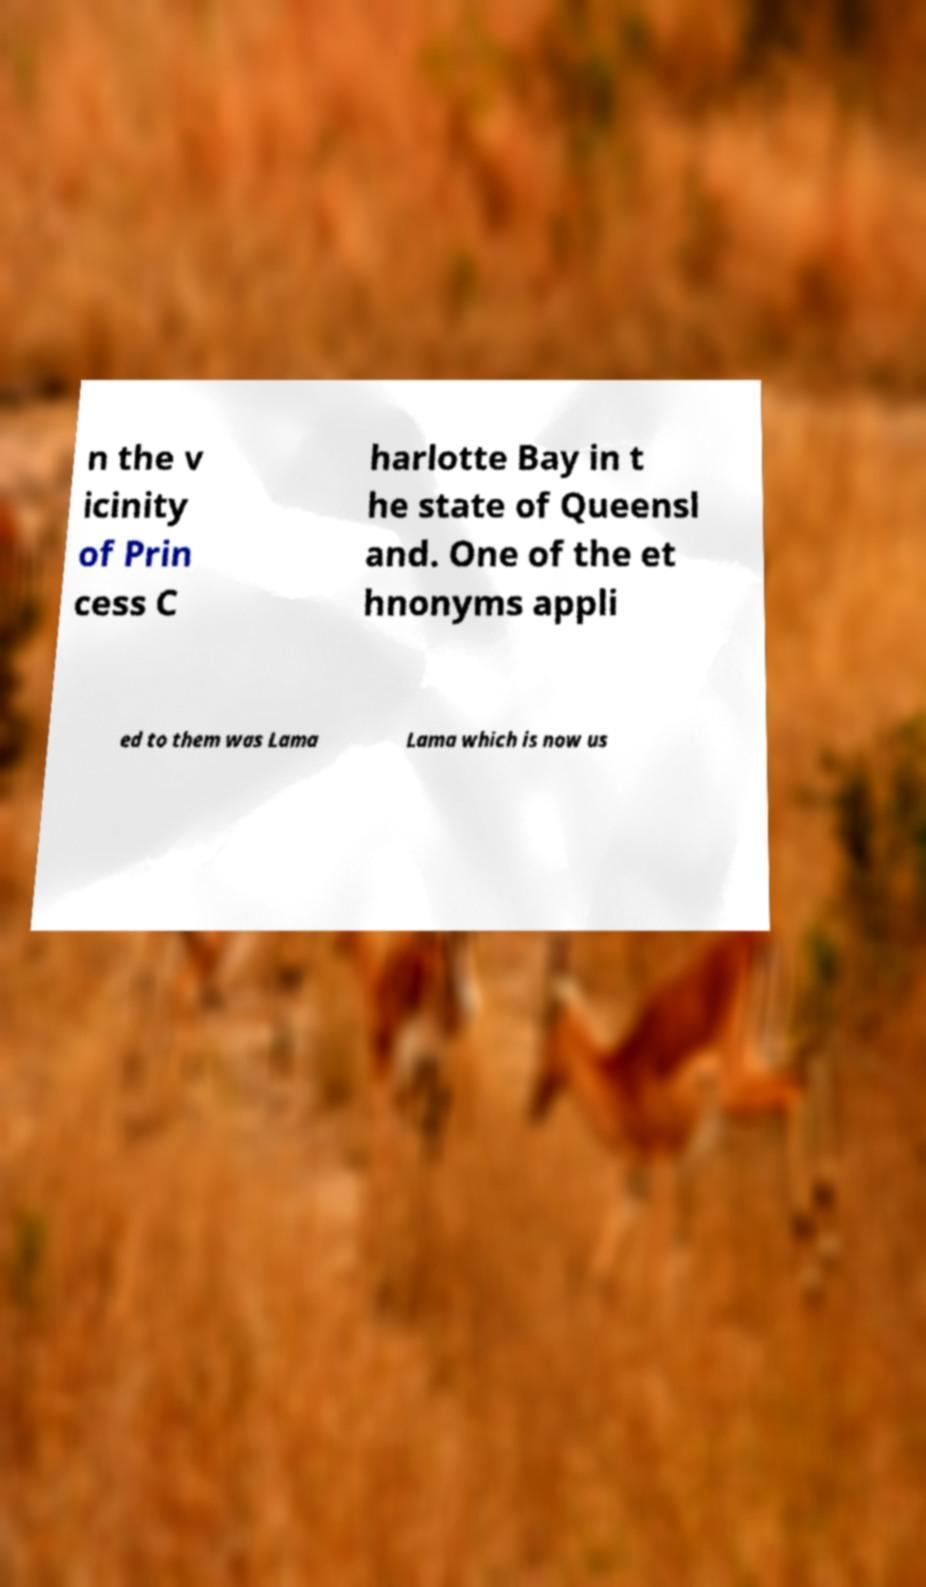Please read and relay the text visible in this image. What does it say? n the v icinity of Prin cess C harlotte Bay in t he state of Queensl and. One of the et hnonyms appli ed to them was Lama Lama which is now us 